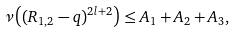Convert formula to latex. <formula><loc_0><loc_0><loc_500><loc_500>\nu \left ( ( R _ { 1 , 2 } - q ) ^ { 2 l + 2 } \right ) \leq A _ { 1 } + A _ { 2 } + A _ { 3 } ,</formula> 